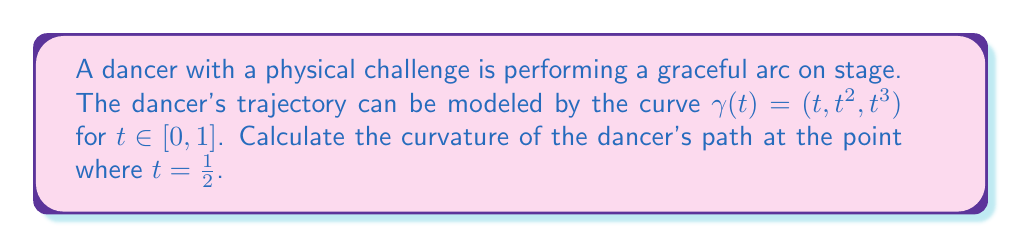Can you answer this question? To calculate the curvature of the dancer's trajectory, we'll follow these steps:

1) The curvature $\kappa$ of a curve $\gamma(t)$ in 3D space is given by:

   $$\kappa = \frac{\|\gamma'(t) \times \gamma''(t)\|}{\|\gamma'(t)\|^3}$$

2) First, let's calculate $\gamma'(t)$ and $\gamma''(t)$:
   
   $\gamma'(t) = (1, 2t, 3t^2)$
   $\gamma''(t) = (0, 2, 6t)$

3) Now, we need to calculate the cross product $\gamma'(t) \times \gamma''(t)$:

   $$\gamma'(t) \times \gamma''(t) = \begin{vmatrix} 
   \mathbf{i} & \mathbf{j} & \mathbf{k} \\
   1 & 2t & 3t^2 \\
   0 & 2 & 6t
   \end{vmatrix} = (6t^2 - 6t^2)\mathbf{i} + (6t - 0)\mathbf{j} + (2 - 4t)\mathbf{k} = 6t\mathbf{j} + (2 - 4t)\mathbf{k}$$

4) The magnitude of this cross product is:

   $$\|\gamma'(t) \times \gamma''(t)\| = \sqrt{(6t)^2 + (2-4t)^2} = \sqrt{36t^2 + 4 - 16t + 16t^2} = \sqrt{52t^2 - 16t + 4}$$

5) Next, we calculate $\|\gamma'(t)\|^3$:

   $$\|\gamma'(t)\|^3 = (1^2 + (2t)^2 + (3t^2)^2)^{3/2} = (1 + 4t^2 + 9t^4)^{3/2}$$

6) Therefore, the curvature is:

   $$\kappa(t) = \frac{\sqrt{52t^2 - 16t + 4}}{(1 + 4t^2 + 9t^4)^{3/2}}$$

7) At $t = \frac{1}{2}$, we have:

   $$\kappa(\frac{1}{2}) = \frac{\sqrt{52(\frac{1}{2})^2 - 16(\frac{1}{2}) + 4}}{(1 + 4(\frac{1}{2})^2 + 9(\frac{1}{2})^4)^{3/2}} = \frac{\sqrt{13 - 8 + 4}}{(1 + 1 + \frac{9}{16})^{3/2}} = \frac{\sqrt{9}}{(\frac{41}{16})^{3/2}} = \frac{3}{(\frac{41}{16})^{3/2}}$$

8) Simplifying:

   $$\kappa(\frac{1}{2}) = \frac{3 \cdot 16^{3/2}}{41^{3/2}} = \frac{3 \cdot 64}{41^{3/2}} = \frac{192}{41^{3/2}}$$
Answer: The curvature of the dancer's trajectory at $t = \frac{1}{2}$ is $\frac{192}{41^{3/2}}$. 